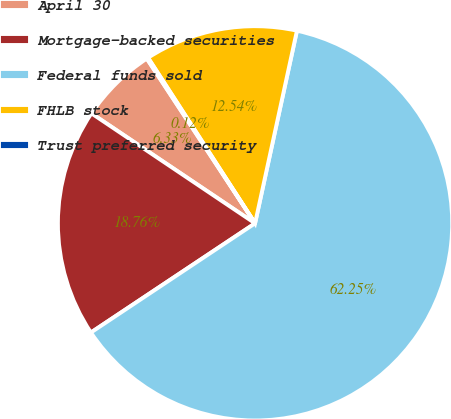<chart> <loc_0><loc_0><loc_500><loc_500><pie_chart><fcel>April 30<fcel>Mortgage-backed securities<fcel>Federal funds sold<fcel>FHLB stock<fcel>Trust preferred security<nl><fcel>6.33%<fcel>18.76%<fcel>62.25%<fcel>12.54%<fcel>0.12%<nl></chart> 